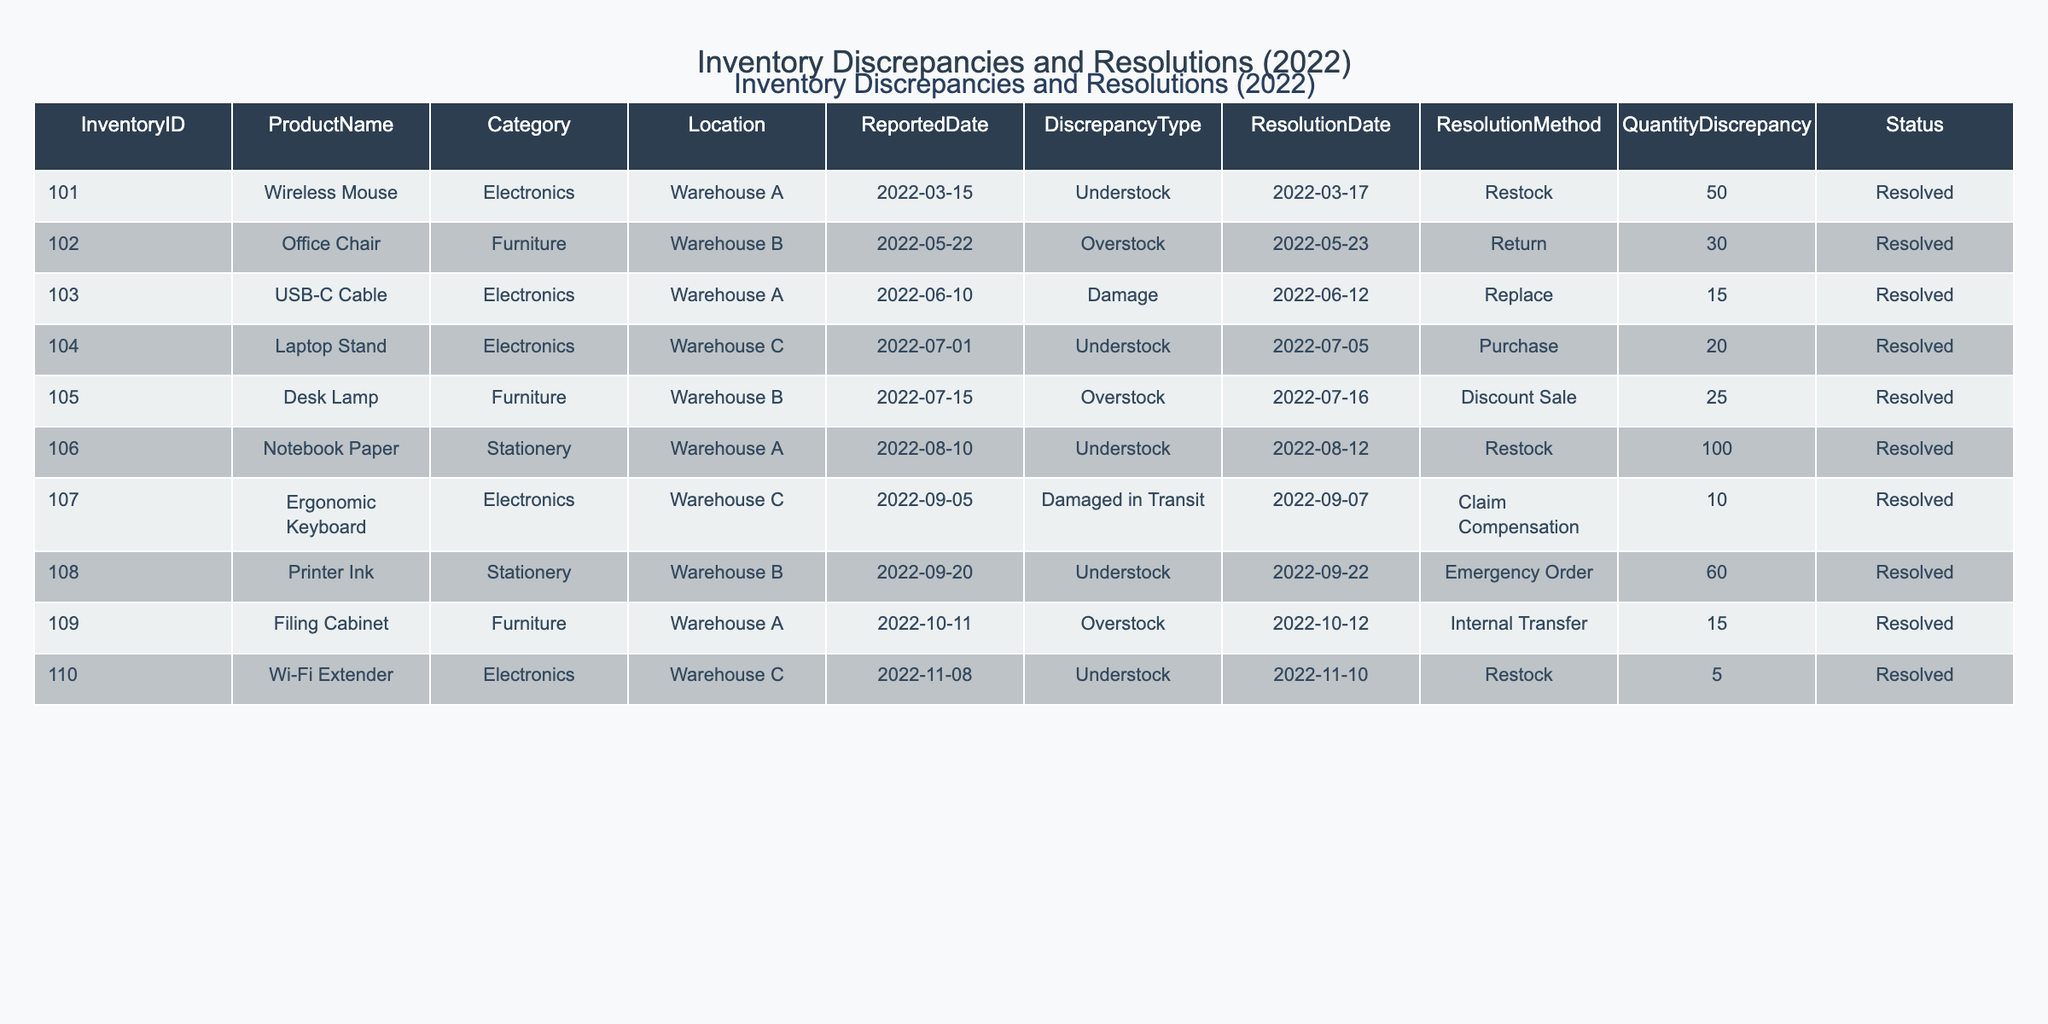What is the total quantity discrepancy reported for the 'Electronics' category? The 'Electronics' category contains three entries: Wireless Mouse (50), USB-C Cable (15), and Laptop Stand (20). To find the total, sum these quantities: 50 + 15 + 20 = 85.
Answer: 85 Which product had the largest quantity discrepancy? The largest quantity discrepancy is found in the Notebook Paper with a quantity discrepancy of 100. To identify this, I reviewed each entry in the "Quantity Discrepancy" column and found that Notebook Paper has the highest value compared to other products.
Answer: Notebook Paper Are there any discrepancies reported for stationery products? Yes, there are discrepancies reported for products in the stationery category. Checking the table, I see that Notebook Paper and Printer Ink both have discrepancies listed.
Answer: Yes What was the most common resolution method used? The most common resolution method is 'Restock.' I can determine this by counting the frequency of each resolution method in the "Resolution Method" column. 'Restock' appears three times, more than any other method.
Answer: Restock How many discrepancies were reported for 'Furniture' products? There are three discrepancies reported for 'Furniture' products. These are the Office Chair, Desk Lamp, and Filing Cabinet. I found these by filtering the table for the 'Furniture' category and counting the entries that matched.
Answer: 3 What is the average quantity discrepancy for all products? To calculate the average, first sum all quantity discrepancies: 50 + 30 + 15 + 20 + 25 + 100 + 10 + 60 + 15 + 5 = 330. Then divide by 10 (the total number of entries): 330 / 10 = 33.
Answer: 33 Is there a discrepancy reported that was resolved by internal transfer? Yes, the Filing Cabinet had a discrepancy resolved by internal transfer. I find this by reviewing the "Resolution Method" column for any entries that state 'Internal Transfer.'
Answer: Yes How many products had a damage-related discrepancy? There are two products with damage-related discrepancies: USB-C Cable (Damage) and Ergonomic Keyboard (Damaged in Transit). I can find these by filtering the entries for the "Discrepancy Type" column for those specifying damage.
Answer: 2 Which warehouse reported the highest total quantity discrepancy? Warehouse A reported the highest total quantity discrepancy of 215 (50 + 100 + 60 + 15). By summing quantity discrepancies for all entries listed under 'Warehouse A,' I identify this total as the highest among all warehouses.
Answer: Warehouse A What was the earliest reported discrepancy date? The earliest reported discrepancy date is March 15, 2022, for the Wireless Mouse. I review the "ReportedDate" column to find the earliest date by comparing all entries.
Answer: March 15, 2022 